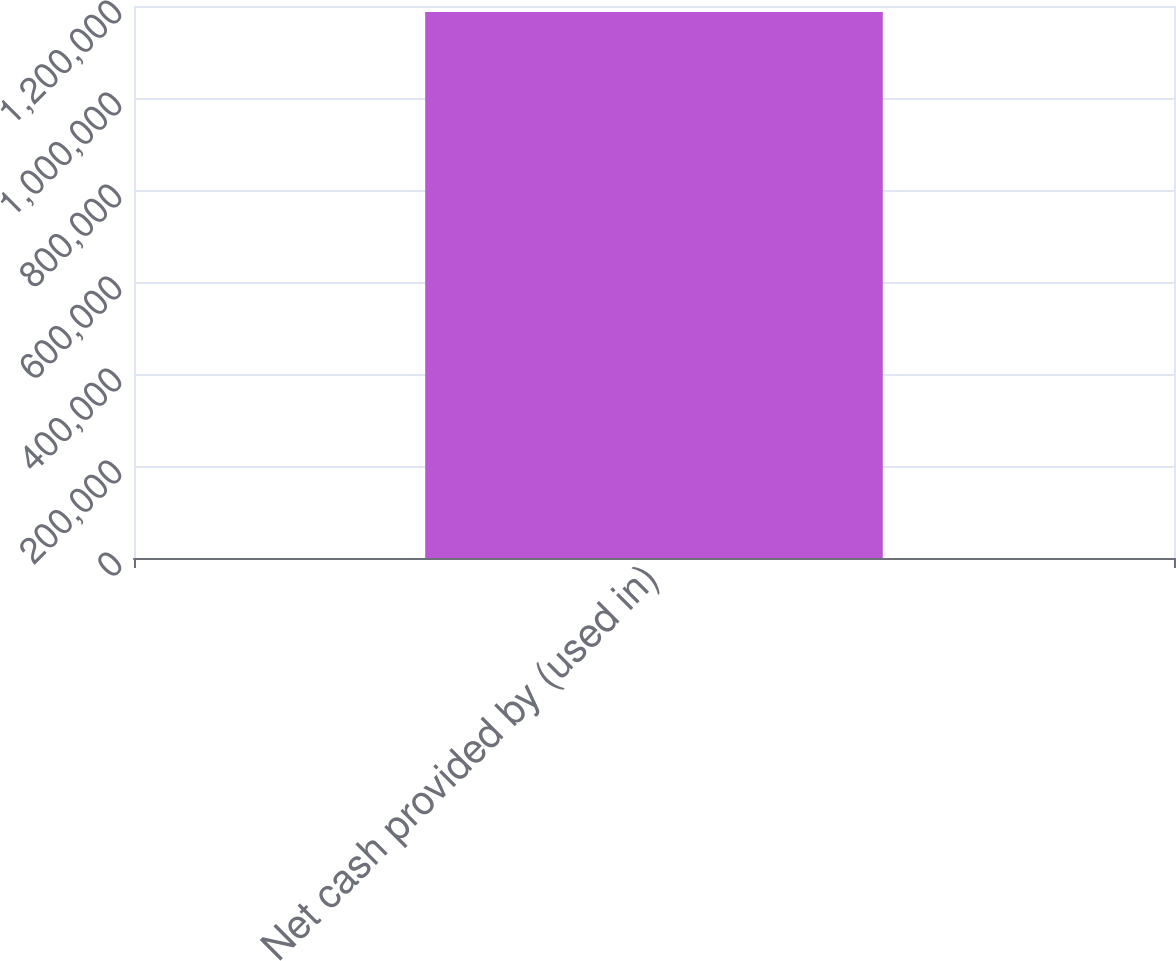<chart> <loc_0><loc_0><loc_500><loc_500><bar_chart><fcel>Net cash provided by (used in)<nl><fcel>1.18694e+06<nl></chart> 